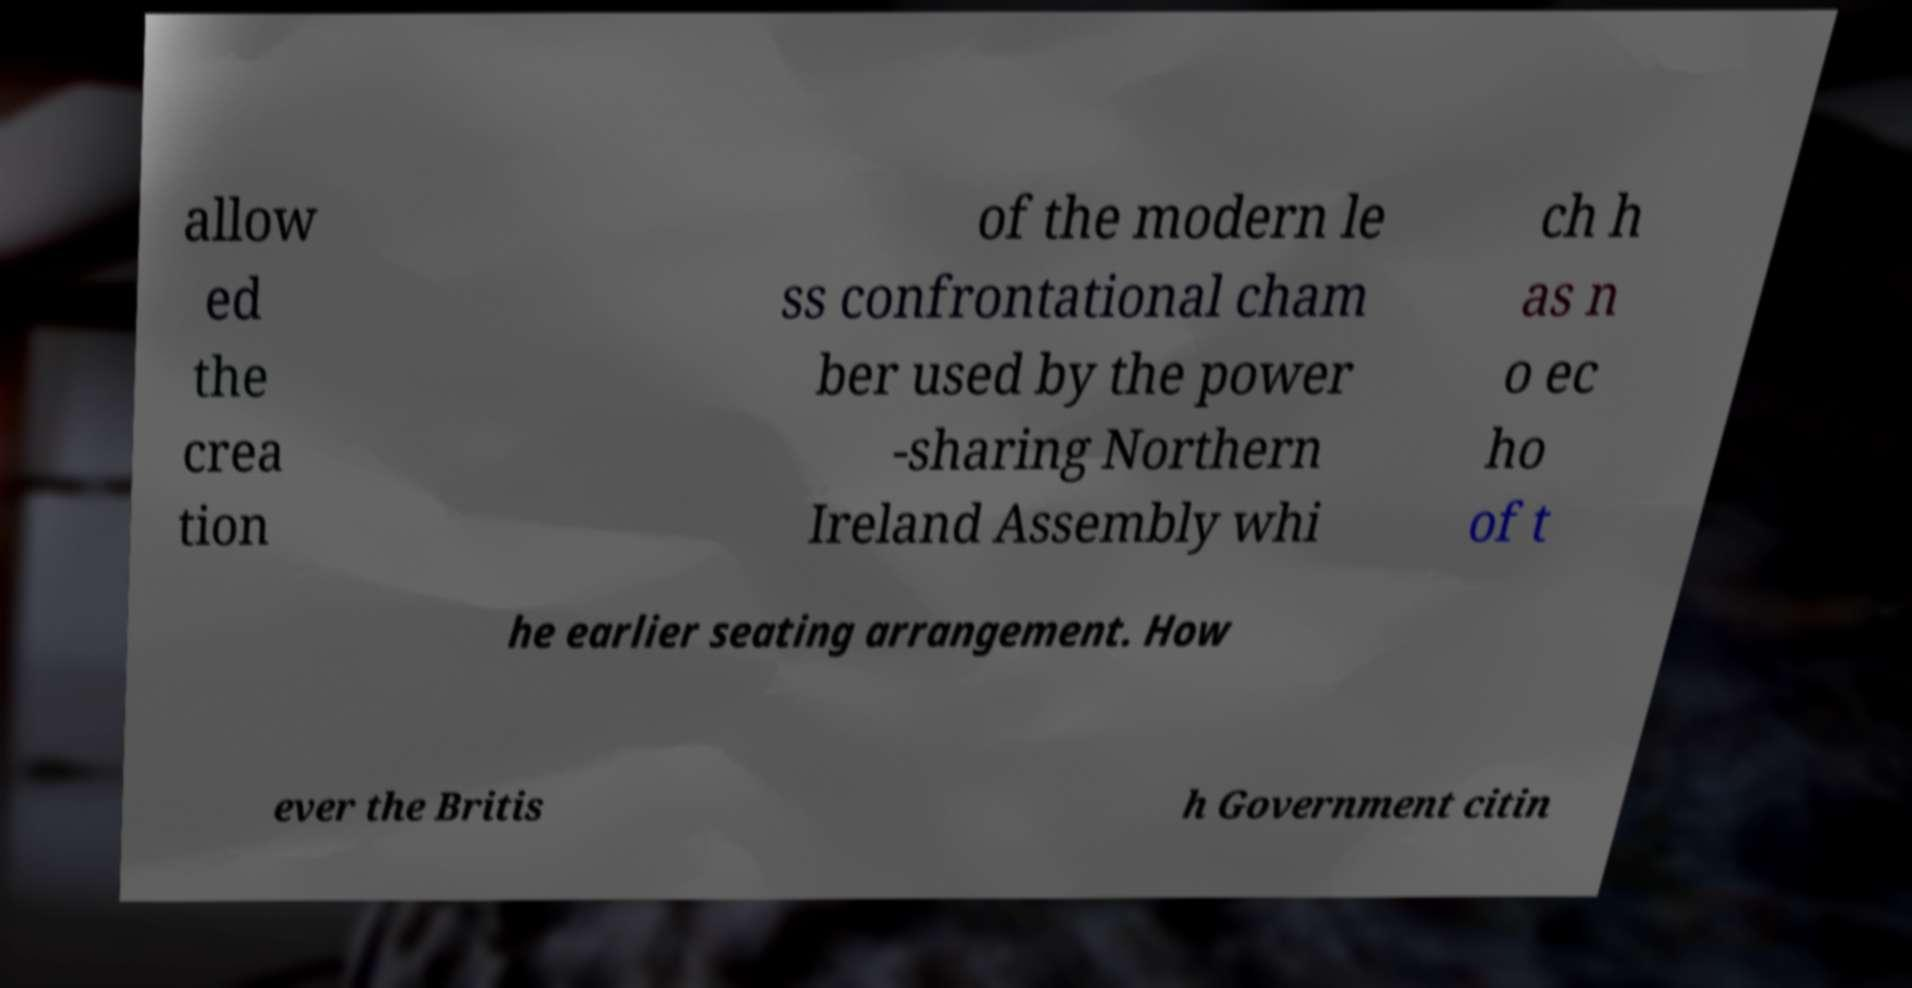For documentation purposes, I need the text within this image transcribed. Could you provide that? allow ed the crea tion of the modern le ss confrontational cham ber used by the power -sharing Northern Ireland Assembly whi ch h as n o ec ho of t he earlier seating arrangement. How ever the Britis h Government citin 